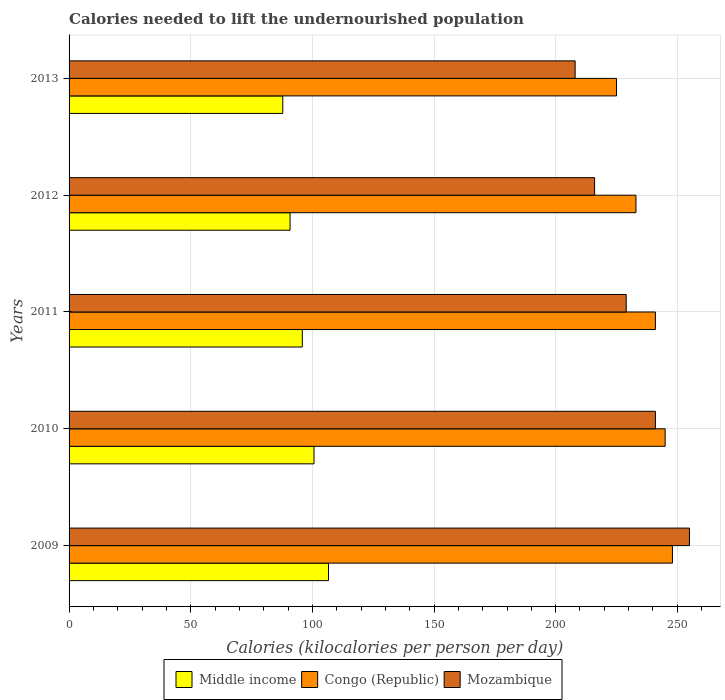How many different coloured bars are there?
Ensure brevity in your answer.  3. Are the number of bars on each tick of the Y-axis equal?
Give a very brief answer. Yes. How many bars are there on the 3rd tick from the top?
Ensure brevity in your answer.  3. What is the label of the 1st group of bars from the top?
Provide a succinct answer. 2013. In how many cases, is the number of bars for a given year not equal to the number of legend labels?
Provide a succinct answer. 0. What is the total calories needed to lift the undernourished population in Middle income in 2010?
Your response must be concise. 100.68. Across all years, what is the maximum total calories needed to lift the undernourished population in Congo (Republic)?
Give a very brief answer. 248. Across all years, what is the minimum total calories needed to lift the undernourished population in Congo (Republic)?
Offer a terse response. 225. In which year was the total calories needed to lift the undernourished population in Middle income maximum?
Your response must be concise. 2009. In which year was the total calories needed to lift the undernourished population in Congo (Republic) minimum?
Your response must be concise. 2013. What is the total total calories needed to lift the undernourished population in Middle income in the graph?
Provide a short and direct response. 481.85. What is the difference between the total calories needed to lift the undernourished population in Mozambique in 2011 and that in 2012?
Your response must be concise. 13. What is the difference between the total calories needed to lift the undernourished population in Middle income in 2009 and the total calories needed to lift the undernourished population in Mozambique in 2013?
Keep it short and to the point. -101.38. What is the average total calories needed to lift the undernourished population in Mozambique per year?
Give a very brief answer. 229.8. In the year 2010, what is the difference between the total calories needed to lift the undernourished population in Mozambique and total calories needed to lift the undernourished population in Middle income?
Ensure brevity in your answer.  140.32. What is the ratio of the total calories needed to lift the undernourished population in Congo (Republic) in 2009 to that in 2011?
Keep it short and to the point. 1.03. Is the difference between the total calories needed to lift the undernourished population in Mozambique in 2011 and 2012 greater than the difference between the total calories needed to lift the undernourished population in Middle income in 2011 and 2012?
Offer a very short reply. Yes. What is the difference between the highest and the second highest total calories needed to lift the undernourished population in Middle income?
Offer a very short reply. 5.95. What is the difference between the highest and the lowest total calories needed to lift the undernourished population in Middle income?
Give a very brief answer. 18.78. Is the sum of the total calories needed to lift the undernourished population in Mozambique in 2009 and 2013 greater than the maximum total calories needed to lift the undernourished population in Congo (Republic) across all years?
Your answer should be compact. Yes. What does the 2nd bar from the top in 2013 represents?
Offer a terse response. Congo (Republic). What does the 2nd bar from the bottom in 2011 represents?
Your response must be concise. Congo (Republic). How many bars are there?
Keep it short and to the point. 15. How many years are there in the graph?
Your response must be concise. 5. What is the difference between two consecutive major ticks on the X-axis?
Provide a succinct answer. 50. Does the graph contain any zero values?
Provide a short and direct response. No. Does the graph contain grids?
Your answer should be compact. Yes. How many legend labels are there?
Ensure brevity in your answer.  3. What is the title of the graph?
Offer a very short reply. Calories needed to lift the undernourished population. Does "Nepal" appear as one of the legend labels in the graph?
Your answer should be compact. No. What is the label or title of the X-axis?
Your response must be concise. Calories (kilocalories per person per day). What is the label or title of the Y-axis?
Make the answer very short. Years. What is the Calories (kilocalories per person per day) in Middle income in 2009?
Provide a short and direct response. 106.62. What is the Calories (kilocalories per person per day) in Congo (Republic) in 2009?
Make the answer very short. 248. What is the Calories (kilocalories per person per day) in Mozambique in 2009?
Offer a very short reply. 255. What is the Calories (kilocalories per person per day) in Middle income in 2010?
Make the answer very short. 100.68. What is the Calories (kilocalories per person per day) of Congo (Republic) in 2010?
Make the answer very short. 245. What is the Calories (kilocalories per person per day) in Mozambique in 2010?
Make the answer very short. 241. What is the Calories (kilocalories per person per day) in Middle income in 2011?
Keep it short and to the point. 95.87. What is the Calories (kilocalories per person per day) in Congo (Republic) in 2011?
Provide a short and direct response. 241. What is the Calories (kilocalories per person per day) of Mozambique in 2011?
Provide a short and direct response. 229. What is the Calories (kilocalories per person per day) in Middle income in 2012?
Provide a succinct answer. 90.84. What is the Calories (kilocalories per person per day) of Congo (Republic) in 2012?
Keep it short and to the point. 233. What is the Calories (kilocalories per person per day) in Mozambique in 2012?
Provide a short and direct response. 216. What is the Calories (kilocalories per person per day) of Middle income in 2013?
Your answer should be compact. 87.84. What is the Calories (kilocalories per person per day) in Congo (Republic) in 2013?
Offer a terse response. 225. What is the Calories (kilocalories per person per day) of Mozambique in 2013?
Your answer should be compact. 208. Across all years, what is the maximum Calories (kilocalories per person per day) of Middle income?
Your answer should be very brief. 106.62. Across all years, what is the maximum Calories (kilocalories per person per day) in Congo (Republic)?
Your response must be concise. 248. Across all years, what is the maximum Calories (kilocalories per person per day) in Mozambique?
Ensure brevity in your answer.  255. Across all years, what is the minimum Calories (kilocalories per person per day) in Middle income?
Provide a short and direct response. 87.84. Across all years, what is the minimum Calories (kilocalories per person per day) in Congo (Republic)?
Keep it short and to the point. 225. Across all years, what is the minimum Calories (kilocalories per person per day) in Mozambique?
Give a very brief answer. 208. What is the total Calories (kilocalories per person per day) in Middle income in the graph?
Offer a terse response. 481.85. What is the total Calories (kilocalories per person per day) in Congo (Republic) in the graph?
Offer a very short reply. 1192. What is the total Calories (kilocalories per person per day) of Mozambique in the graph?
Provide a short and direct response. 1149. What is the difference between the Calories (kilocalories per person per day) in Middle income in 2009 and that in 2010?
Provide a succinct answer. 5.95. What is the difference between the Calories (kilocalories per person per day) in Middle income in 2009 and that in 2011?
Ensure brevity in your answer.  10.76. What is the difference between the Calories (kilocalories per person per day) in Congo (Republic) in 2009 and that in 2011?
Your response must be concise. 7. What is the difference between the Calories (kilocalories per person per day) in Mozambique in 2009 and that in 2011?
Your answer should be compact. 26. What is the difference between the Calories (kilocalories per person per day) in Middle income in 2009 and that in 2012?
Your answer should be very brief. 15.79. What is the difference between the Calories (kilocalories per person per day) of Middle income in 2009 and that in 2013?
Provide a succinct answer. 18.78. What is the difference between the Calories (kilocalories per person per day) in Middle income in 2010 and that in 2011?
Your response must be concise. 4.81. What is the difference between the Calories (kilocalories per person per day) of Middle income in 2010 and that in 2012?
Offer a very short reply. 9.84. What is the difference between the Calories (kilocalories per person per day) in Mozambique in 2010 and that in 2012?
Keep it short and to the point. 25. What is the difference between the Calories (kilocalories per person per day) in Middle income in 2010 and that in 2013?
Offer a very short reply. 12.83. What is the difference between the Calories (kilocalories per person per day) of Mozambique in 2010 and that in 2013?
Provide a succinct answer. 33. What is the difference between the Calories (kilocalories per person per day) in Middle income in 2011 and that in 2012?
Give a very brief answer. 5.03. What is the difference between the Calories (kilocalories per person per day) in Congo (Republic) in 2011 and that in 2012?
Offer a very short reply. 8. What is the difference between the Calories (kilocalories per person per day) of Mozambique in 2011 and that in 2012?
Give a very brief answer. 13. What is the difference between the Calories (kilocalories per person per day) of Middle income in 2011 and that in 2013?
Offer a very short reply. 8.02. What is the difference between the Calories (kilocalories per person per day) of Congo (Republic) in 2011 and that in 2013?
Keep it short and to the point. 16. What is the difference between the Calories (kilocalories per person per day) of Middle income in 2012 and that in 2013?
Give a very brief answer. 2.99. What is the difference between the Calories (kilocalories per person per day) in Congo (Republic) in 2012 and that in 2013?
Offer a terse response. 8. What is the difference between the Calories (kilocalories per person per day) of Mozambique in 2012 and that in 2013?
Ensure brevity in your answer.  8. What is the difference between the Calories (kilocalories per person per day) of Middle income in 2009 and the Calories (kilocalories per person per day) of Congo (Republic) in 2010?
Provide a short and direct response. -138.38. What is the difference between the Calories (kilocalories per person per day) in Middle income in 2009 and the Calories (kilocalories per person per day) in Mozambique in 2010?
Give a very brief answer. -134.38. What is the difference between the Calories (kilocalories per person per day) of Middle income in 2009 and the Calories (kilocalories per person per day) of Congo (Republic) in 2011?
Ensure brevity in your answer.  -134.38. What is the difference between the Calories (kilocalories per person per day) in Middle income in 2009 and the Calories (kilocalories per person per day) in Mozambique in 2011?
Your answer should be very brief. -122.38. What is the difference between the Calories (kilocalories per person per day) in Middle income in 2009 and the Calories (kilocalories per person per day) in Congo (Republic) in 2012?
Your answer should be very brief. -126.38. What is the difference between the Calories (kilocalories per person per day) of Middle income in 2009 and the Calories (kilocalories per person per day) of Mozambique in 2012?
Provide a short and direct response. -109.38. What is the difference between the Calories (kilocalories per person per day) of Middle income in 2009 and the Calories (kilocalories per person per day) of Congo (Republic) in 2013?
Your answer should be compact. -118.38. What is the difference between the Calories (kilocalories per person per day) in Middle income in 2009 and the Calories (kilocalories per person per day) in Mozambique in 2013?
Provide a short and direct response. -101.38. What is the difference between the Calories (kilocalories per person per day) in Congo (Republic) in 2009 and the Calories (kilocalories per person per day) in Mozambique in 2013?
Keep it short and to the point. 40. What is the difference between the Calories (kilocalories per person per day) in Middle income in 2010 and the Calories (kilocalories per person per day) in Congo (Republic) in 2011?
Offer a terse response. -140.32. What is the difference between the Calories (kilocalories per person per day) of Middle income in 2010 and the Calories (kilocalories per person per day) of Mozambique in 2011?
Ensure brevity in your answer.  -128.32. What is the difference between the Calories (kilocalories per person per day) of Congo (Republic) in 2010 and the Calories (kilocalories per person per day) of Mozambique in 2011?
Offer a very short reply. 16. What is the difference between the Calories (kilocalories per person per day) of Middle income in 2010 and the Calories (kilocalories per person per day) of Congo (Republic) in 2012?
Provide a succinct answer. -132.32. What is the difference between the Calories (kilocalories per person per day) in Middle income in 2010 and the Calories (kilocalories per person per day) in Mozambique in 2012?
Make the answer very short. -115.32. What is the difference between the Calories (kilocalories per person per day) of Congo (Republic) in 2010 and the Calories (kilocalories per person per day) of Mozambique in 2012?
Ensure brevity in your answer.  29. What is the difference between the Calories (kilocalories per person per day) in Middle income in 2010 and the Calories (kilocalories per person per day) in Congo (Republic) in 2013?
Offer a very short reply. -124.32. What is the difference between the Calories (kilocalories per person per day) of Middle income in 2010 and the Calories (kilocalories per person per day) of Mozambique in 2013?
Your answer should be very brief. -107.32. What is the difference between the Calories (kilocalories per person per day) in Congo (Republic) in 2010 and the Calories (kilocalories per person per day) in Mozambique in 2013?
Your response must be concise. 37. What is the difference between the Calories (kilocalories per person per day) in Middle income in 2011 and the Calories (kilocalories per person per day) in Congo (Republic) in 2012?
Offer a terse response. -137.13. What is the difference between the Calories (kilocalories per person per day) of Middle income in 2011 and the Calories (kilocalories per person per day) of Mozambique in 2012?
Offer a terse response. -120.13. What is the difference between the Calories (kilocalories per person per day) in Congo (Republic) in 2011 and the Calories (kilocalories per person per day) in Mozambique in 2012?
Your response must be concise. 25. What is the difference between the Calories (kilocalories per person per day) of Middle income in 2011 and the Calories (kilocalories per person per day) of Congo (Republic) in 2013?
Provide a succinct answer. -129.13. What is the difference between the Calories (kilocalories per person per day) of Middle income in 2011 and the Calories (kilocalories per person per day) of Mozambique in 2013?
Give a very brief answer. -112.13. What is the difference between the Calories (kilocalories per person per day) of Congo (Republic) in 2011 and the Calories (kilocalories per person per day) of Mozambique in 2013?
Make the answer very short. 33. What is the difference between the Calories (kilocalories per person per day) of Middle income in 2012 and the Calories (kilocalories per person per day) of Congo (Republic) in 2013?
Provide a succinct answer. -134.16. What is the difference between the Calories (kilocalories per person per day) of Middle income in 2012 and the Calories (kilocalories per person per day) of Mozambique in 2013?
Your response must be concise. -117.16. What is the difference between the Calories (kilocalories per person per day) in Congo (Republic) in 2012 and the Calories (kilocalories per person per day) in Mozambique in 2013?
Keep it short and to the point. 25. What is the average Calories (kilocalories per person per day) of Middle income per year?
Provide a short and direct response. 96.37. What is the average Calories (kilocalories per person per day) of Congo (Republic) per year?
Provide a short and direct response. 238.4. What is the average Calories (kilocalories per person per day) in Mozambique per year?
Keep it short and to the point. 229.8. In the year 2009, what is the difference between the Calories (kilocalories per person per day) of Middle income and Calories (kilocalories per person per day) of Congo (Republic)?
Your answer should be compact. -141.38. In the year 2009, what is the difference between the Calories (kilocalories per person per day) of Middle income and Calories (kilocalories per person per day) of Mozambique?
Offer a terse response. -148.38. In the year 2010, what is the difference between the Calories (kilocalories per person per day) of Middle income and Calories (kilocalories per person per day) of Congo (Republic)?
Your response must be concise. -144.32. In the year 2010, what is the difference between the Calories (kilocalories per person per day) of Middle income and Calories (kilocalories per person per day) of Mozambique?
Give a very brief answer. -140.32. In the year 2010, what is the difference between the Calories (kilocalories per person per day) in Congo (Republic) and Calories (kilocalories per person per day) in Mozambique?
Offer a terse response. 4. In the year 2011, what is the difference between the Calories (kilocalories per person per day) of Middle income and Calories (kilocalories per person per day) of Congo (Republic)?
Offer a very short reply. -145.13. In the year 2011, what is the difference between the Calories (kilocalories per person per day) in Middle income and Calories (kilocalories per person per day) in Mozambique?
Keep it short and to the point. -133.13. In the year 2011, what is the difference between the Calories (kilocalories per person per day) of Congo (Republic) and Calories (kilocalories per person per day) of Mozambique?
Make the answer very short. 12. In the year 2012, what is the difference between the Calories (kilocalories per person per day) of Middle income and Calories (kilocalories per person per day) of Congo (Republic)?
Your response must be concise. -142.16. In the year 2012, what is the difference between the Calories (kilocalories per person per day) of Middle income and Calories (kilocalories per person per day) of Mozambique?
Make the answer very short. -125.16. In the year 2013, what is the difference between the Calories (kilocalories per person per day) in Middle income and Calories (kilocalories per person per day) in Congo (Republic)?
Give a very brief answer. -137.16. In the year 2013, what is the difference between the Calories (kilocalories per person per day) of Middle income and Calories (kilocalories per person per day) of Mozambique?
Make the answer very short. -120.16. In the year 2013, what is the difference between the Calories (kilocalories per person per day) of Congo (Republic) and Calories (kilocalories per person per day) of Mozambique?
Offer a terse response. 17. What is the ratio of the Calories (kilocalories per person per day) in Middle income in 2009 to that in 2010?
Give a very brief answer. 1.06. What is the ratio of the Calories (kilocalories per person per day) of Congo (Republic) in 2009 to that in 2010?
Ensure brevity in your answer.  1.01. What is the ratio of the Calories (kilocalories per person per day) in Mozambique in 2009 to that in 2010?
Your answer should be compact. 1.06. What is the ratio of the Calories (kilocalories per person per day) of Middle income in 2009 to that in 2011?
Your answer should be compact. 1.11. What is the ratio of the Calories (kilocalories per person per day) in Congo (Republic) in 2009 to that in 2011?
Offer a very short reply. 1.03. What is the ratio of the Calories (kilocalories per person per day) in Mozambique in 2009 to that in 2011?
Offer a terse response. 1.11. What is the ratio of the Calories (kilocalories per person per day) in Middle income in 2009 to that in 2012?
Give a very brief answer. 1.17. What is the ratio of the Calories (kilocalories per person per day) of Congo (Republic) in 2009 to that in 2012?
Make the answer very short. 1.06. What is the ratio of the Calories (kilocalories per person per day) in Mozambique in 2009 to that in 2012?
Keep it short and to the point. 1.18. What is the ratio of the Calories (kilocalories per person per day) in Middle income in 2009 to that in 2013?
Your answer should be compact. 1.21. What is the ratio of the Calories (kilocalories per person per day) of Congo (Republic) in 2009 to that in 2013?
Your answer should be very brief. 1.1. What is the ratio of the Calories (kilocalories per person per day) in Mozambique in 2009 to that in 2013?
Ensure brevity in your answer.  1.23. What is the ratio of the Calories (kilocalories per person per day) in Middle income in 2010 to that in 2011?
Ensure brevity in your answer.  1.05. What is the ratio of the Calories (kilocalories per person per day) of Congo (Republic) in 2010 to that in 2011?
Provide a succinct answer. 1.02. What is the ratio of the Calories (kilocalories per person per day) in Mozambique in 2010 to that in 2011?
Keep it short and to the point. 1.05. What is the ratio of the Calories (kilocalories per person per day) of Middle income in 2010 to that in 2012?
Make the answer very short. 1.11. What is the ratio of the Calories (kilocalories per person per day) in Congo (Republic) in 2010 to that in 2012?
Your answer should be very brief. 1.05. What is the ratio of the Calories (kilocalories per person per day) in Mozambique in 2010 to that in 2012?
Offer a terse response. 1.12. What is the ratio of the Calories (kilocalories per person per day) in Middle income in 2010 to that in 2013?
Make the answer very short. 1.15. What is the ratio of the Calories (kilocalories per person per day) of Congo (Republic) in 2010 to that in 2013?
Provide a succinct answer. 1.09. What is the ratio of the Calories (kilocalories per person per day) of Mozambique in 2010 to that in 2013?
Keep it short and to the point. 1.16. What is the ratio of the Calories (kilocalories per person per day) in Middle income in 2011 to that in 2012?
Keep it short and to the point. 1.06. What is the ratio of the Calories (kilocalories per person per day) of Congo (Republic) in 2011 to that in 2012?
Give a very brief answer. 1.03. What is the ratio of the Calories (kilocalories per person per day) of Mozambique in 2011 to that in 2012?
Your answer should be compact. 1.06. What is the ratio of the Calories (kilocalories per person per day) in Middle income in 2011 to that in 2013?
Give a very brief answer. 1.09. What is the ratio of the Calories (kilocalories per person per day) in Congo (Republic) in 2011 to that in 2013?
Your answer should be very brief. 1.07. What is the ratio of the Calories (kilocalories per person per day) in Mozambique in 2011 to that in 2013?
Ensure brevity in your answer.  1.1. What is the ratio of the Calories (kilocalories per person per day) of Middle income in 2012 to that in 2013?
Offer a very short reply. 1.03. What is the ratio of the Calories (kilocalories per person per day) of Congo (Republic) in 2012 to that in 2013?
Your response must be concise. 1.04. What is the difference between the highest and the second highest Calories (kilocalories per person per day) of Middle income?
Give a very brief answer. 5.95. What is the difference between the highest and the lowest Calories (kilocalories per person per day) in Middle income?
Provide a short and direct response. 18.78. What is the difference between the highest and the lowest Calories (kilocalories per person per day) in Congo (Republic)?
Provide a short and direct response. 23. What is the difference between the highest and the lowest Calories (kilocalories per person per day) in Mozambique?
Your response must be concise. 47. 